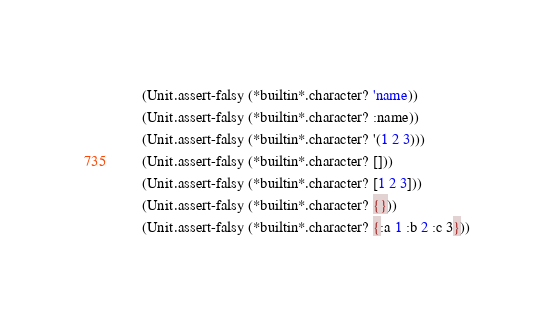<code> <loc_0><loc_0><loc_500><loc_500><_Scheme_>    (Unit.assert-falsy (*builtin*.character? 'name))
    (Unit.assert-falsy (*builtin*.character? :name))
    (Unit.assert-falsy (*builtin*.character? '(1 2 3)))
    (Unit.assert-falsy (*builtin*.character? []))
    (Unit.assert-falsy (*builtin*.character? [1 2 3]))
    (Unit.assert-falsy (*builtin*.character? {}))
    (Unit.assert-falsy (*builtin*.character? {:a 1 :b 2 :c 3}))</code> 